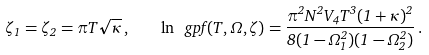<formula> <loc_0><loc_0><loc_500><loc_500>\zeta _ { 1 } = \zeta _ { 2 } = \pi T \sqrt { \kappa } \, , \quad \ln \ g p f ( T , \Omega , \zeta ) = \frac { \pi ^ { 2 } N ^ { 2 } V _ { 4 } T ^ { 3 } ( 1 + \kappa ) ^ { 2 } } { 8 ( 1 - \Omega _ { 1 } ^ { 2 } ) ( 1 - \Omega _ { 2 } ^ { 2 } ) } \, .</formula> 